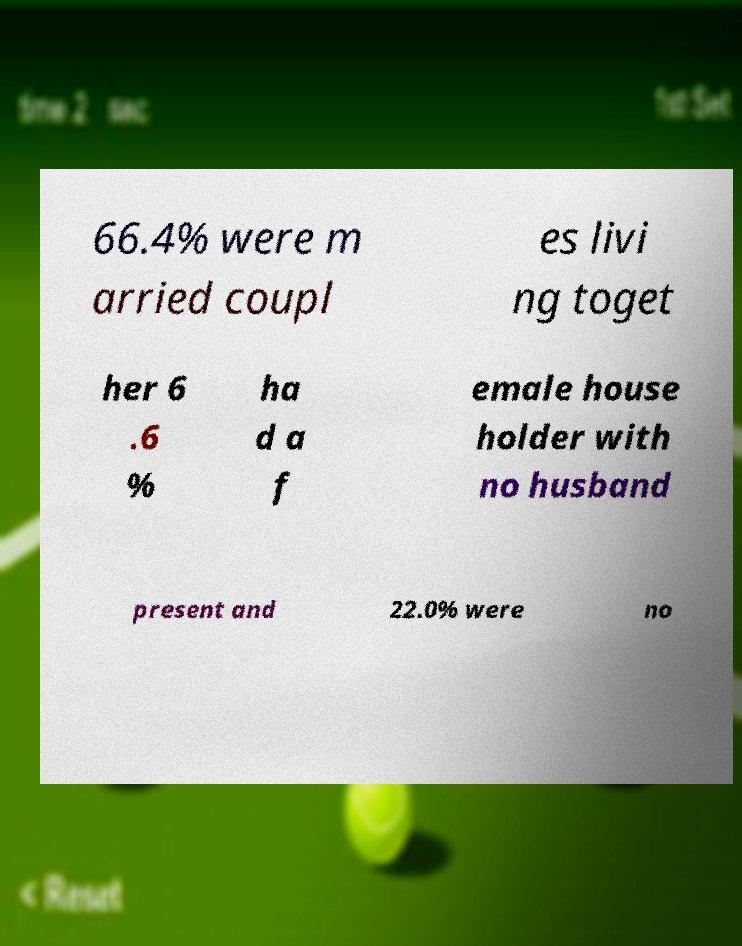For documentation purposes, I need the text within this image transcribed. Could you provide that? 66.4% were m arried coupl es livi ng toget her 6 .6 % ha d a f emale house holder with no husband present and 22.0% were no 